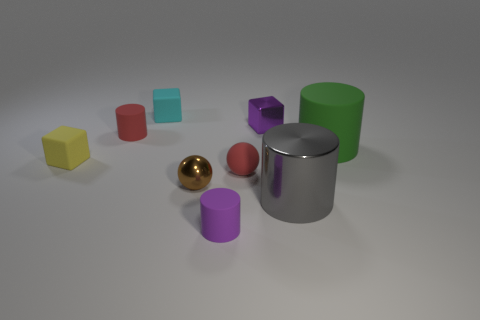There is a small purple cube behind the tiny yellow rubber object; are there any large gray objects that are on the left side of it?
Provide a short and direct response. No. Are the cube that is on the right side of the matte sphere and the gray object made of the same material?
Your response must be concise. Yes. What number of small objects are both on the left side of the purple rubber cylinder and behind the small red cylinder?
Offer a terse response. 1. How many tiny things have the same material as the small yellow block?
Make the answer very short. 4. The other small cylinder that is the same material as the small purple cylinder is what color?
Your answer should be compact. Red. Are there fewer brown shiny objects than brown blocks?
Your response must be concise. No. What material is the small purple object that is behind the red cylinder in front of the small purple object behind the gray shiny thing?
Keep it short and to the point. Metal. What is the gray thing made of?
Offer a very short reply. Metal. There is a cube that is right of the purple rubber object; does it have the same color as the rubber cylinder that is in front of the large rubber cylinder?
Ensure brevity in your answer.  Yes. Is the number of shiny objects greater than the number of tiny spheres?
Your response must be concise. Yes. 